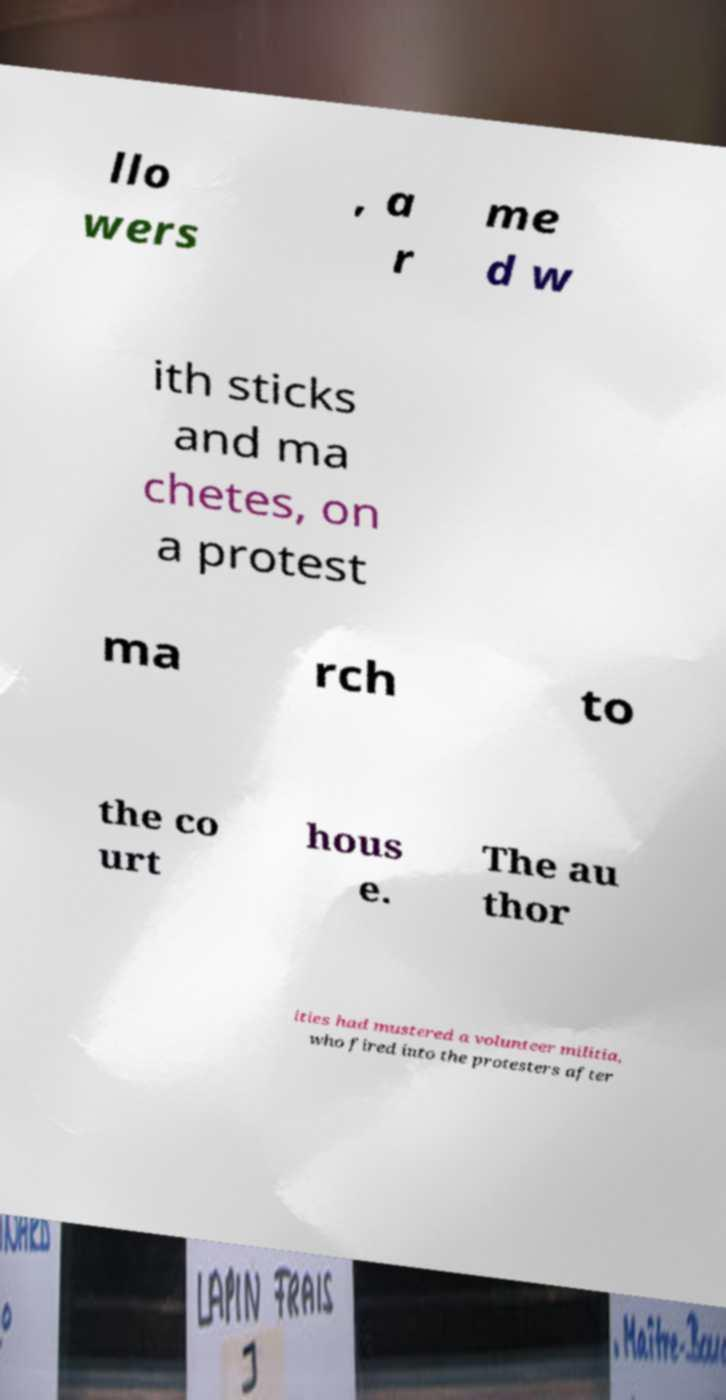Can you read and provide the text displayed in the image?This photo seems to have some interesting text. Can you extract and type it out for me? llo wers , a r me d w ith sticks and ma chetes, on a protest ma rch to the co urt hous e. The au thor ities had mustered a volunteer militia, who fired into the protesters after 